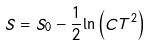Convert formula to latex. <formula><loc_0><loc_0><loc_500><loc_500>S = S _ { 0 } - \frac { 1 } { 2 } { \ln } \left ( C T ^ { 2 } \right )</formula> 